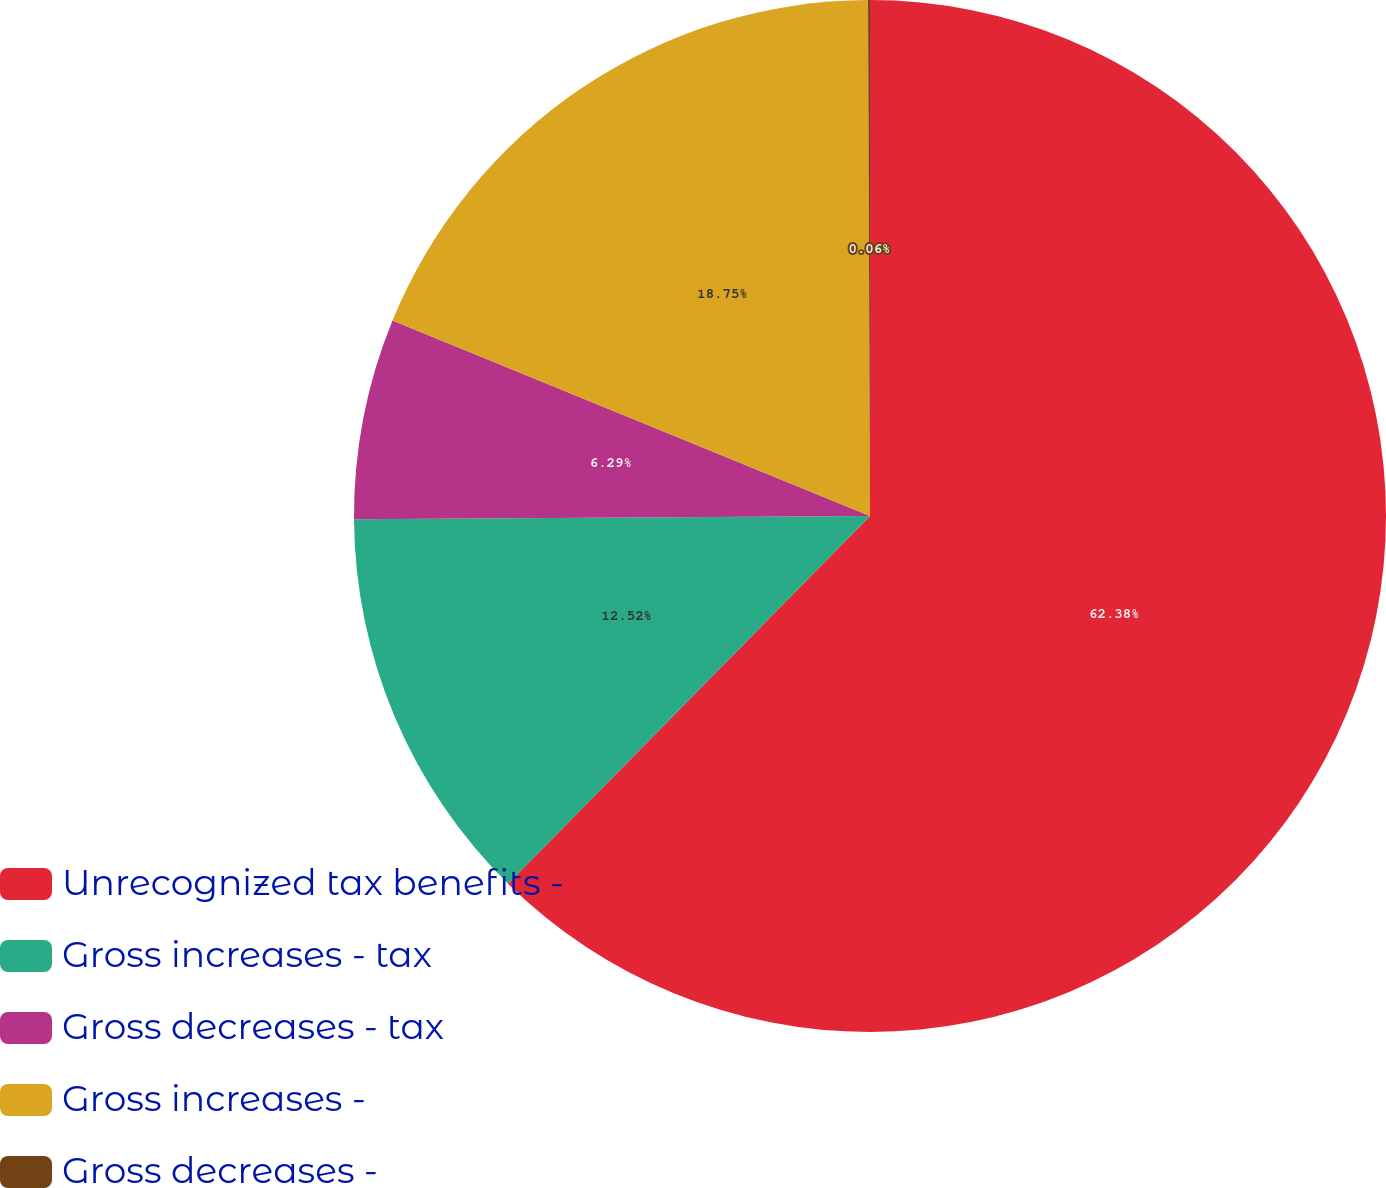Convert chart. <chart><loc_0><loc_0><loc_500><loc_500><pie_chart><fcel>Unrecognized tax benefits -<fcel>Gross increases - tax<fcel>Gross decreases - tax<fcel>Gross increases -<fcel>Gross decreases -<nl><fcel>62.37%<fcel>12.52%<fcel>6.29%<fcel>18.75%<fcel>0.06%<nl></chart> 